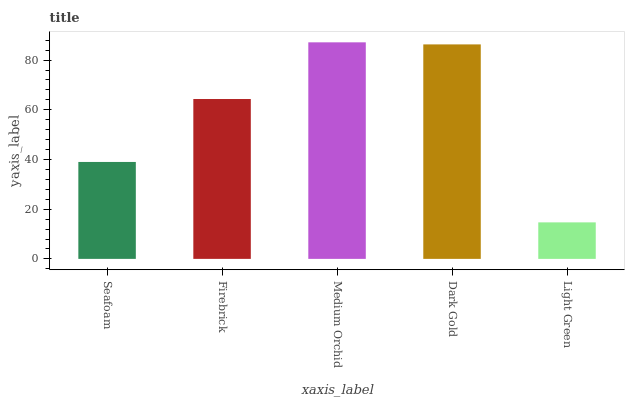Is Light Green the minimum?
Answer yes or no. Yes. Is Medium Orchid the maximum?
Answer yes or no. Yes. Is Firebrick the minimum?
Answer yes or no. No. Is Firebrick the maximum?
Answer yes or no. No. Is Firebrick greater than Seafoam?
Answer yes or no. Yes. Is Seafoam less than Firebrick?
Answer yes or no. Yes. Is Seafoam greater than Firebrick?
Answer yes or no. No. Is Firebrick less than Seafoam?
Answer yes or no. No. Is Firebrick the high median?
Answer yes or no. Yes. Is Firebrick the low median?
Answer yes or no. Yes. Is Dark Gold the high median?
Answer yes or no. No. Is Dark Gold the low median?
Answer yes or no. No. 